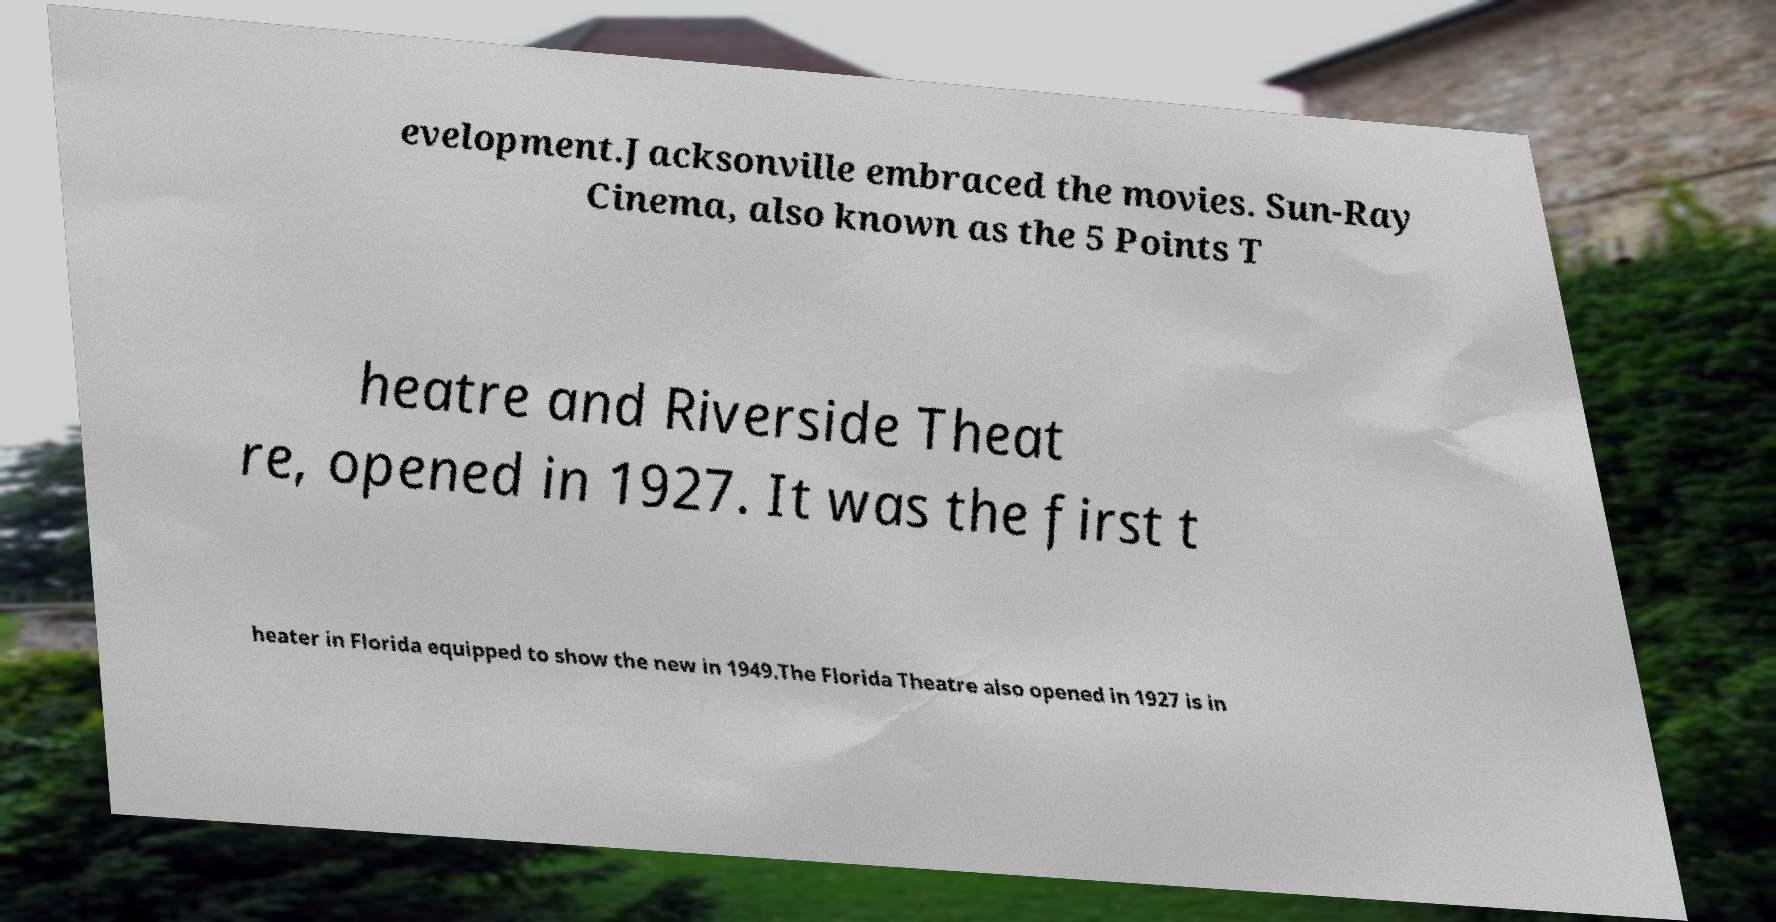There's text embedded in this image that I need extracted. Can you transcribe it verbatim? evelopment.Jacksonville embraced the movies. Sun-Ray Cinema, also known as the 5 Points T heatre and Riverside Theat re, opened in 1927. It was the first t heater in Florida equipped to show the new in 1949.The Florida Theatre also opened in 1927 is in 